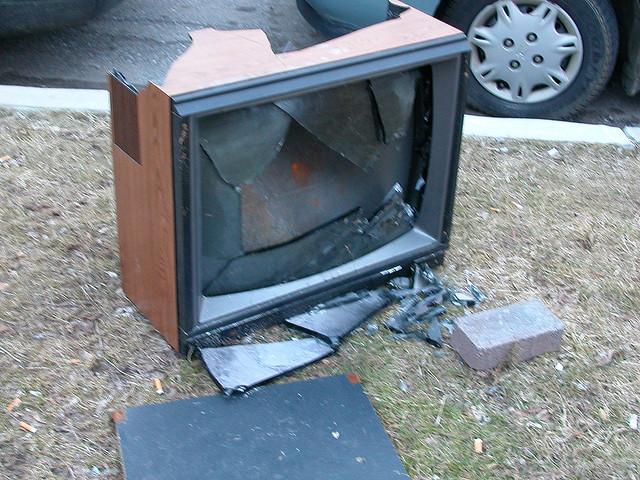Is the television in good working order?
Answer briefly. No. Is the television turned on?
Give a very brief answer. No. IS there a brick in the picture?
Write a very short answer. Yes. 